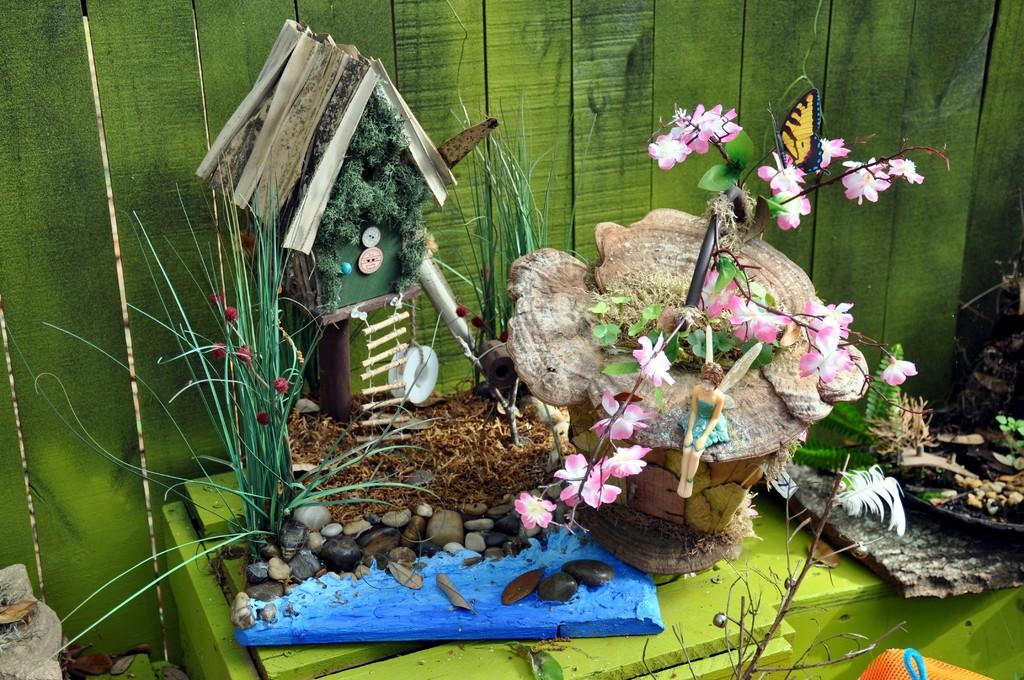What is placed on the table in the image? There is a showpiece on a table in the image. What is the color of the table? The table is green in color. What can be seen in the background of the image? There is a green color wooden wall in the background. What type of living organisms are visible in the image? There are plants visible in the image. What else is present in the image besides the showpiece and plants? There are toys and a butterfly present in the image. What type of teeth can be seen in the image? There are no teeth visible in the image. What knowledge is being shared in the image? There is no indication of any knowledge being shared in the image. 